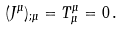Convert formula to latex. <formula><loc_0><loc_0><loc_500><loc_500>( J ^ { \mu } ) _ { ; \mu } = T ^ { \mu } _ { \mu } = 0 \, .</formula> 